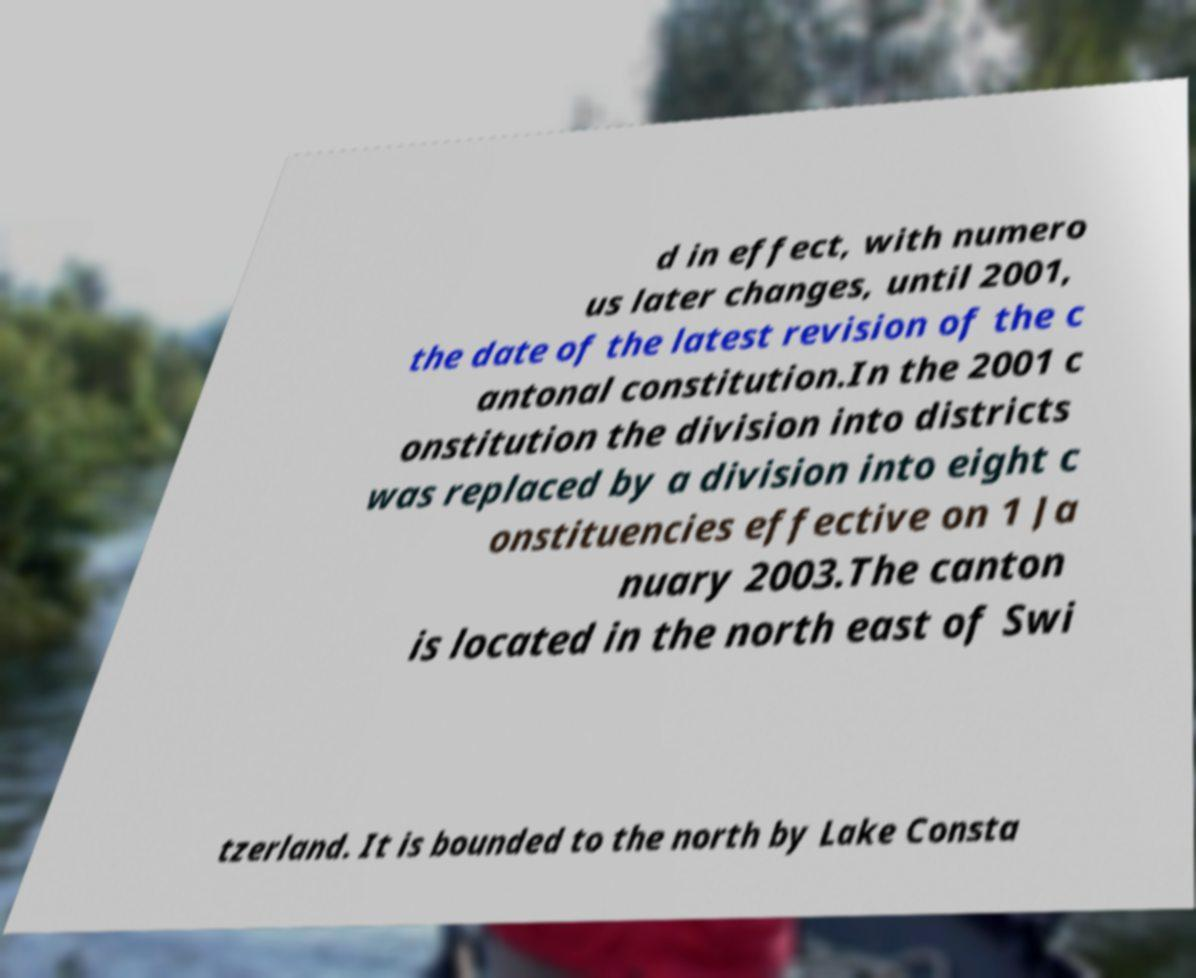Could you extract and type out the text from this image? d in effect, with numero us later changes, until 2001, the date of the latest revision of the c antonal constitution.In the 2001 c onstitution the division into districts was replaced by a division into eight c onstituencies effective on 1 Ja nuary 2003.The canton is located in the north east of Swi tzerland. It is bounded to the north by Lake Consta 